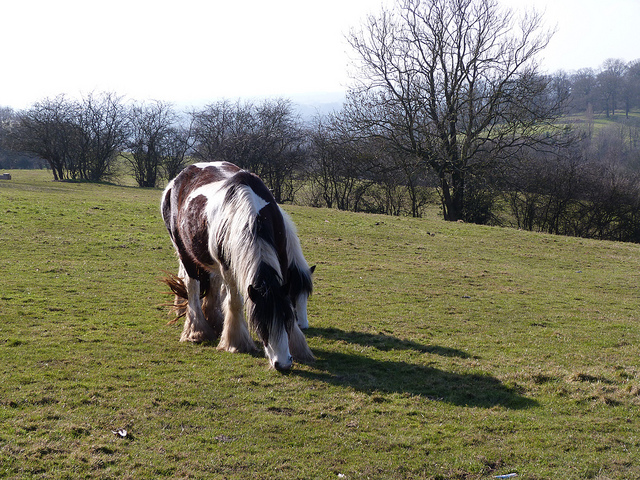What is covering the ground? The ground is covered with grass, providing a natural environment for the horse to graze on. 